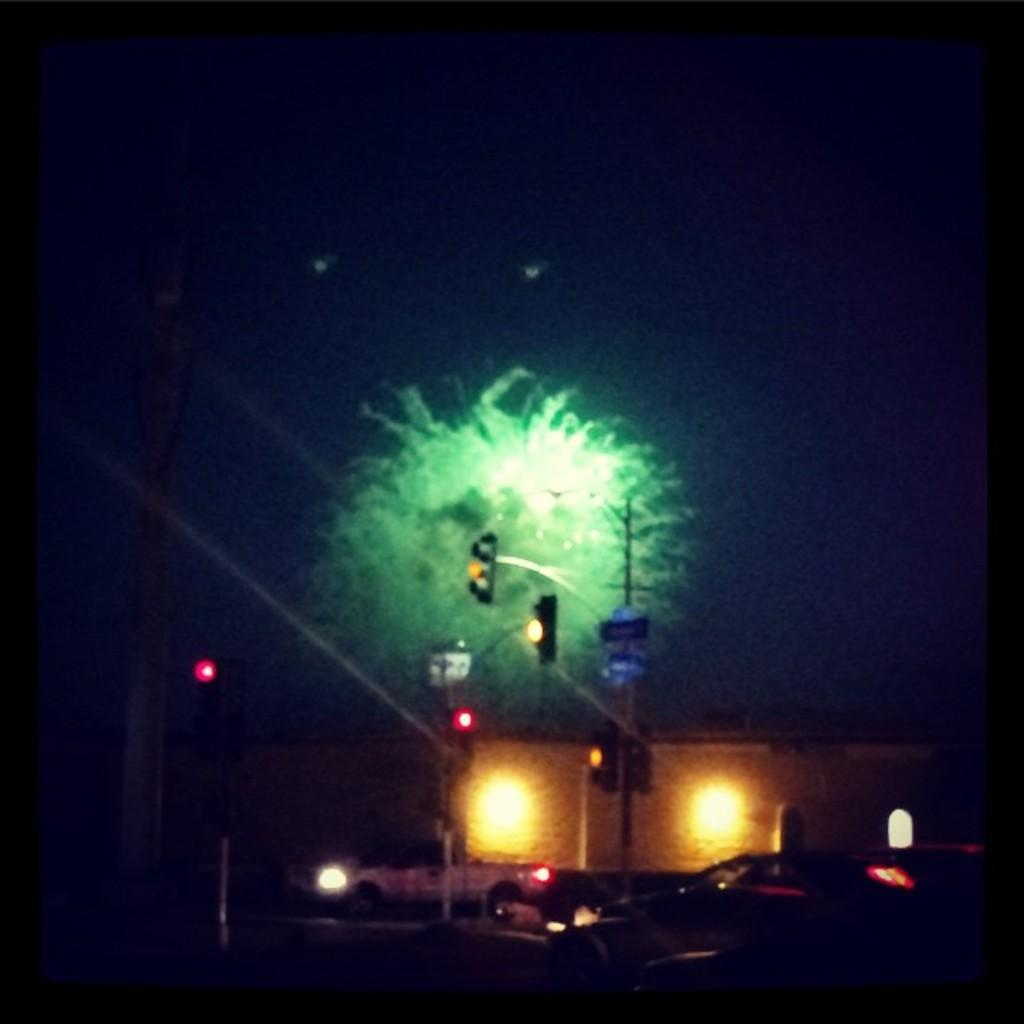What time of day is depicted in the image? The image is taken during night mode. What type of structure can be seen in the image? There is a building in the image. What is happening on the road in the image? Vehicles are passing on the road in the image. What helps regulate the traffic flow in the image? Traffic lights are visible in the image. What type of club can be seen in the image? There is no club present in the image. Are there any skateboarders visible in the image? There are no skateboarders visible in the image. 